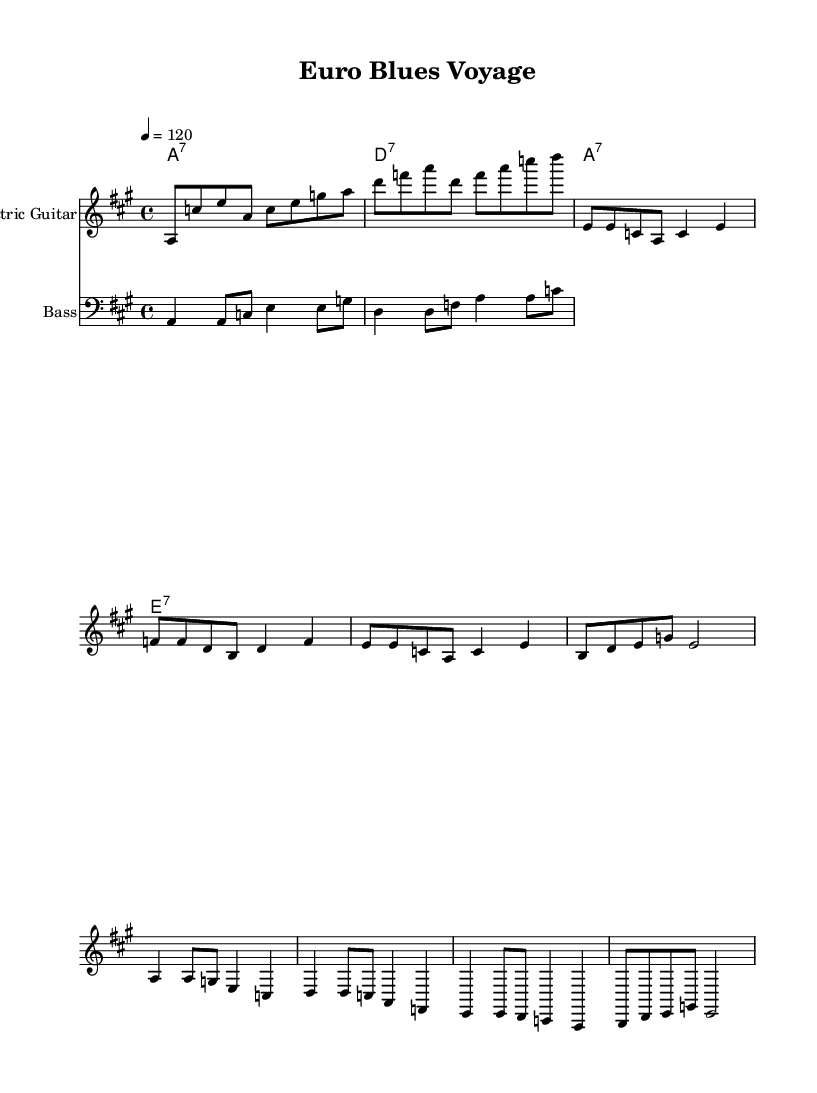What is the key signature of this music? The key signature is indicated at the beginning of the score. It shows three sharps, which corresponds to the key of A major.
Answer: A major What is the time signature of the piece? The time signature is found near the beginning of the score before the first measure. It is 4/4, meaning there are four beats per measure.
Answer: 4/4 What is the tempo marking of the music? The tempo marking is located at the beginning of the score. It is indicated as "4 = 120," which suggests the quarter note gets 120 beats per minute.
Answer: 120 How many measures are in the melody verse section? The melody verse section consists of four lines, and each line contains four measures, making a total of sixteen measures for the verse.
Answer: 16 Which chord is played in the first measure? The chord names at the top of the score indicate that the first chord is A7, which corresponds to the first measure of the chord progression.
Answer: A7 What type of instrument is indicated for the staff labeled "Electric Guitar"? The instrument name above the staff makes clear that this staff is for "Electric Guitar."
Answer: Electric Guitar What characteristic makes this piece fit into the electric blues genre? The piece features a typical blues structure with chords A7, D7, and E7, along with a distinctive electric guitar riff and rhythm which are hallmarks of electric blues music.
Answer: Electric guitar riff 